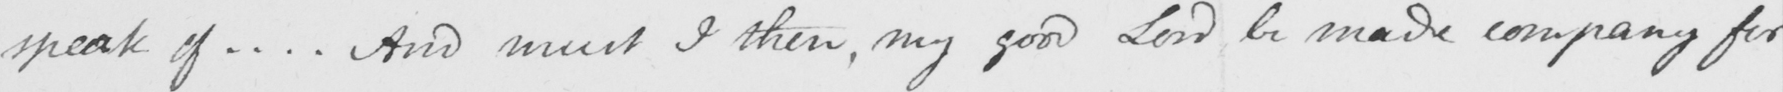Please transcribe the handwritten text in this image. speak of ... . And must I then , my good Lord be made company for 